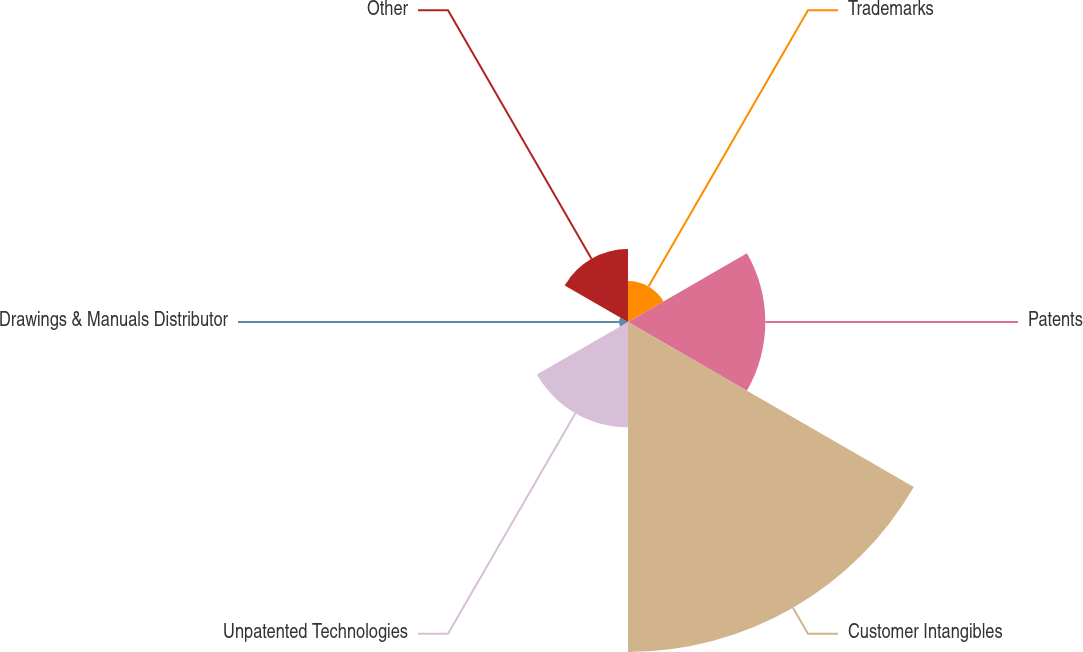Convert chart. <chart><loc_0><loc_0><loc_500><loc_500><pie_chart><fcel>Trademarks<fcel>Patents<fcel>Customer Intangibles<fcel>Unpatented Technologies<fcel>Drawings & Manuals Distributor<fcel>Other<nl><fcel>5.9%<fcel>19.74%<fcel>47.44%<fcel>15.13%<fcel>1.28%<fcel>10.51%<nl></chart> 